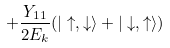Convert formula to latex. <formula><loc_0><loc_0><loc_500><loc_500>+ \frac { Y _ { 1 1 } } { 2 E _ { k } } ( | \uparrow , \downarrow \rangle + | \downarrow , \uparrow \rangle )</formula> 